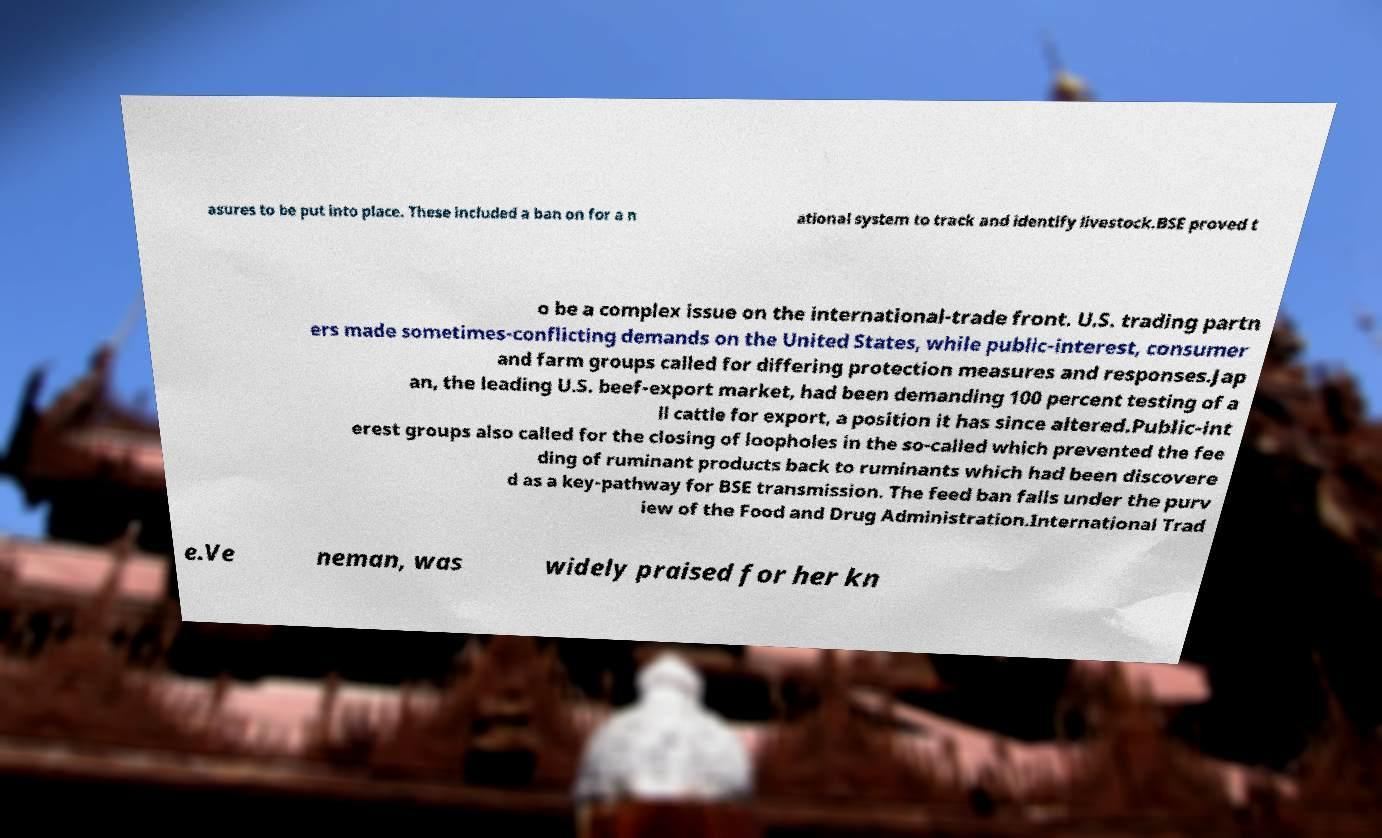Can you accurately transcribe the text from the provided image for me? asures to be put into place. These included a ban on for a n ational system to track and identify livestock.BSE proved t o be a complex issue on the international-trade front. U.S. trading partn ers made sometimes-conflicting demands on the United States, while public-interest, consumer and farm groups called for differing protection measures and responses.Jap an, the leading U.S. beef-export market, had been demanding 100 percent testing of a ll cattle for export, a position it has since altered.Public-int erest groups also called for the closing of loopholes in the so-called which prevented the fee ding of ruminant products back to ruminants which had been discovere d as a key-pathway for BSE transmission. The feed ban falls under the purv iew of the Food and Drug Administration.International Trad e.Ve neman, was widely praised for her kn 